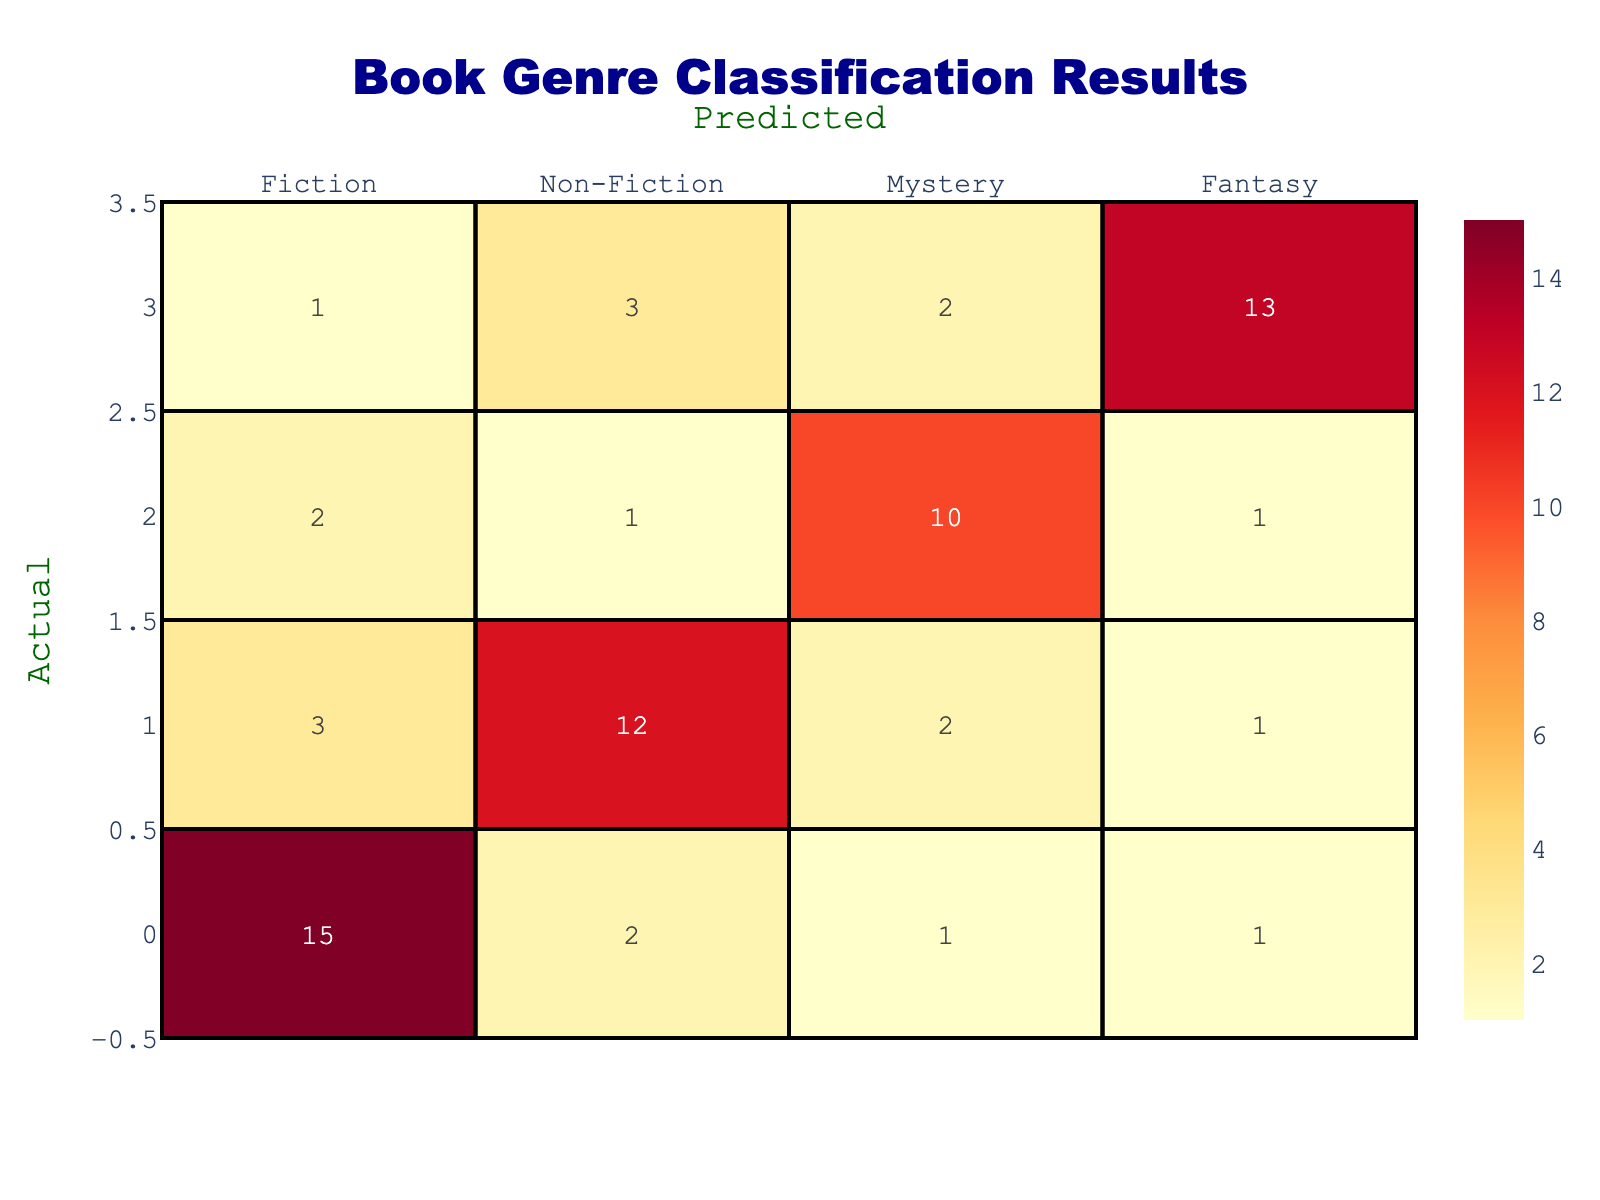What is the number of Fiction books that were correctly classified? In the table, the cell under the "Fiction" column and "Fiction" row shows 15. This indicates that 15 Fiction books were correctly identified as Fiction.
Answer: 15 How many Non-Fiction books were misclassified as Fiction? The table shows that under the "Fiction" column and "Non-Fiction" row, there are 3 books. This means that 3 Non-Fiction books were incorrectly classified as Fiction.
Answer: 3 What is the total number of Fantasy books in the dataset? To find the total number of Fantasy books, we need to sum the values in the "Fantasy" column: 1 (Fiction) + 1 (Non-Fiction) + 1 (Mystery) + 13 (Fantasy) = 16.
Answer: 16 Is it true that more Mystery books were misclassified as Fiction than Non-Fiction? Looking at the "Fiction" column, there are 2 Mystery books misclassified, while in the "Non-Fiction" column, there is only 1. Therefore, it is true that more Mystery books were misclassified as Fiction compared to Non-Fiction.
Answer: Yes What percentage of the total predictions were correctly classified for each genre? We need to calculate the total for each genre: for Fiction, it's 15 correct out of (15+2+1+1) = 19 total. For Non-Fiction, it's 12 out of 18 total. For Mystery, it's 10 out of 14 total. For Fantasy, it's 13 out of 19 total. The percentages are (15/19)*100 for Fiction, (12/18)*100 for Non-Fiction, (10/14)*100 for Mystery, and (13/19)*100 for Fantasy. The correct percentages are approximately 78.95%, 66.67%, 71.43%, and 68.42%, respectively.
Answer: Fiction: 78.95%, Non-Fiction: 66.67%, Mystery: 71.43%, Fantasy: 68.42% How many books were classified as Mystery in total? To find the total number of books classified as Mystery, we need to sum the values in the "Mystery" column: 1 (Fiction) + 2 (Non-Fiction) + 10 (Mystery) + 2 (Fantasy) = 15.
Answer: 15 What is the difference between the number of correctly classified Non-Fiction books and incorrectly classified Non-Fiction books? The correctly classified Non-Fiction number is 12, while the incorrectly classified ones are 3 (as Fiction) and 2 (as Mystery), totaling 5. The difference is 12 - 5 = 7.
Answer: 7 What is the total number of books that were classified as Fiction? To find the total number of books classified as Fiction, we sum all the values in the "Fiction" row: 15 (correctly classified) + 2 (Non-Fiction) + 1 (Mystery) + 1 (Fantasy) = 19.
Answer: 19 How many books overall were predicted as Fantasy? To determine the total predicted as Fantasy, sum the values in the "Fantasy" row: 1 (Fiction) + 1 (Non-Fiction) + 1 (Mystery) + 13 (correct) = 16.
Answer: 16 